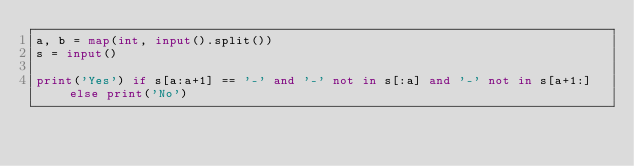<code> <loc_0><loc_0><loc_500><loc_500><_Python_>a, b = map(int, input().split())
s = input()

print('Yes') if s[a:a+1] == '-' and '-' not in s[:a] and '-' not in s[a+1:] else print('No')
</code> 